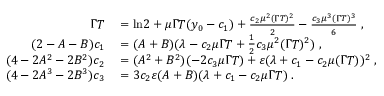<formula> <loc_0><loc_0><loc_500><loc_500>\begin{array} { r l } { \Gamma T } & = \ln \, 2 + \mu \Gamma T ( y _ { 0 } - c _ { 1 } ) + \frac { c _ { 2 } \mu ^ { 2 } ( \Gamma T ) ^ { 2 } } { 2 } - \frac { c _ { 3 } \mu ^ { 3 } ( \Gamma T ) ^ { 3 } } { 6 } \, , } \\ { ( 2 - A - B ) c _ { 1 } } & = ( A + B ) ( \lambda - c _ { 2 } \mu \Gamma T + \frac { 1 } { 2 } c _ { 3 } \mu ^ { 2 } ( \Gamma T ) ^ { 2 } ) \, , } \\ { ( 4 - 2 A ^ { 2 } - 2 B ^ { 2 } ) c _ { 2 } } & = ( A ^ { 2 } + B ^ { 2 } ) ( - 2 c _ { 3 } \mu \Gamma T ) + \varepsilon ( \lambda + c _ { 1 } - c _ { 2 } \mu ( \Gamma T ) ) ^ { 2 } \, , } \\ { ( 4 - 2 A ^ { 3 } - 2 B ^ { 3 } ) c _ { 3 } } & = 3 c _ { 2 } \varepsilon ( A + B ) ( \lambda + c _ { 1 } - c _ { 2 } \mu \Gamma T ) \, . } \end{array}</formula> 